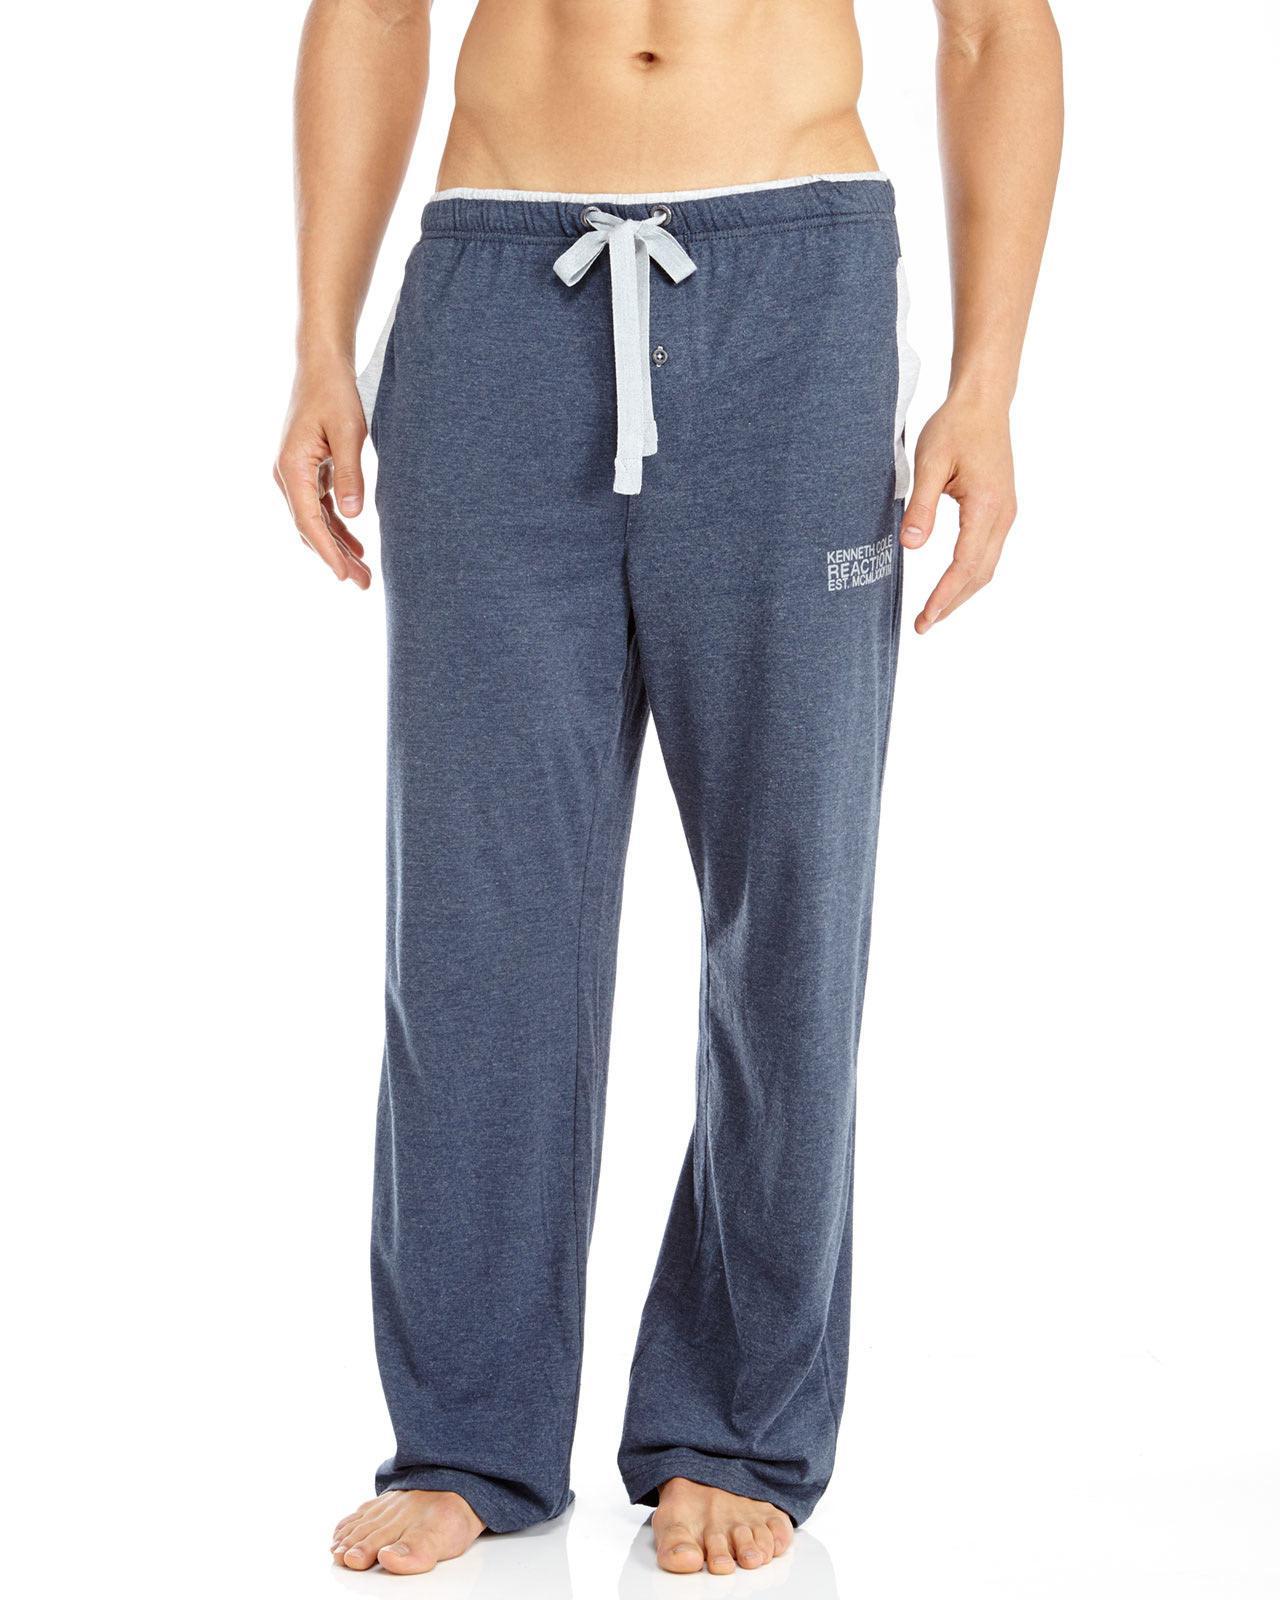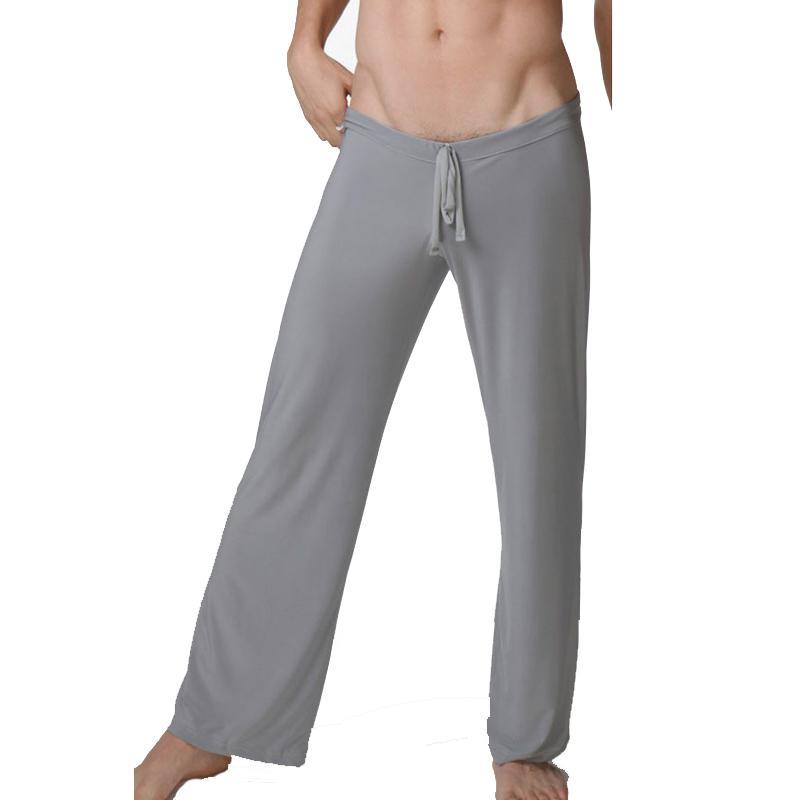The first image is the image on the left, the second image is the image on the right. Examine the images to the left and right. Is the description "One of two models shown is wearing shoes and the other is barefoot." accurate? Answer yes or no. No. 